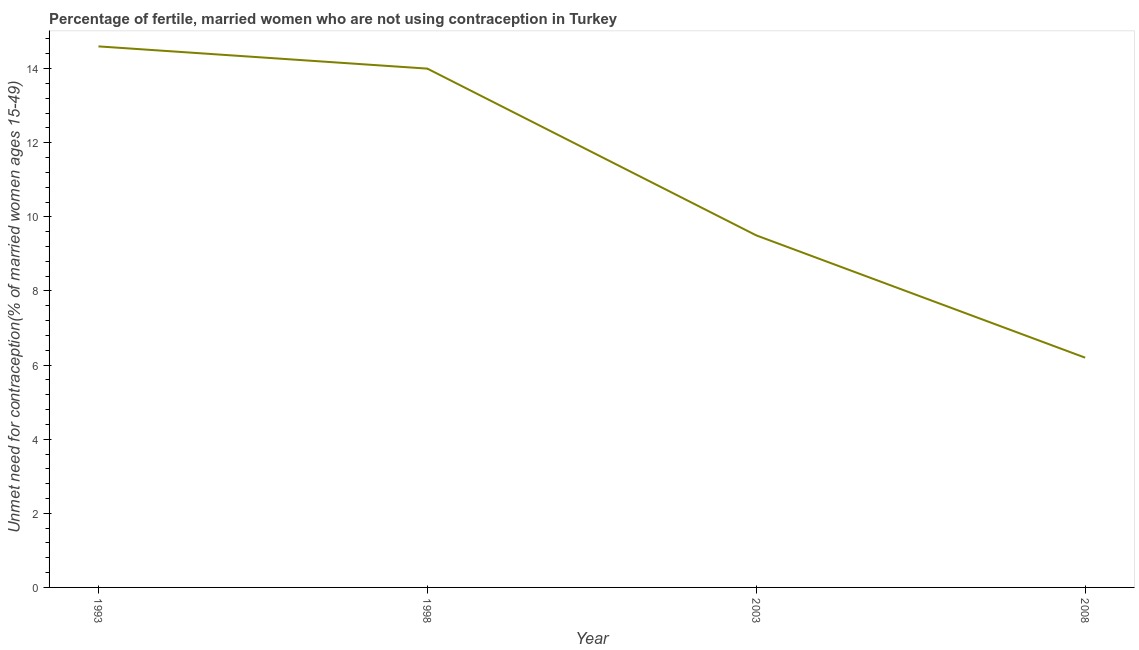What is the number of married women who are not using contraception in 2008?
Your answer should be very brief. 6.2. In which year was the number of married women who are not using contraception maximum?
Ensure brevity in your answer.  1993. What is the sum of the number of married women who are not using contraception?
Keep it short and to the point. 44.3. What is the average number of married women who are not using contraception per year?
Your answer should be compact. 11.08. What is the median number of married women who are not using contraception?
Your answer should be compact. 11.75. In how many years, is the number of married women who are not using contraception greater than 8.4 %?
Your answer should be compact. 3. What is the ratio of the number of married women who are not using contraception in 1993 to that in 1998?
Ensure brevity in your answer.  1.04. Is the number of married women who are not using contraception in 2003 less than that in 2008?
Give a very brief answer. No. What is the difference between the highest and the second highest number of married women who are not using contraception?
Offer a terse response. 0.6. What is the difference between the highest and the lowest number of married women who are not using contraception?
Your answer should be very brief. 8.4. Does the number of married women who are not using contraception monotonically increase over the years?
Make the answer very short. No. Are the values on the major ticks of Y-axis written in scientific E-notation?
Your answer should be very brief. No. Does the graph contain any zero values?
Provide a succinct answer. No. Does the graph contain grids?
Your response must be concise. No. What is the title of the graph?
Ensure brevity in your answer.  Percentage of fertile, married women who are not using contraception in Turkey. What is the label or title of the X-axis?
Your answer should be very brief. Year. What is the label or title of the Y-axis?
Ensure brevity in your answer.   Unmet need for contraception(% of married women ages 15-49). What is the  Unmet need for contraception(% of married women ages 15-49) of 1993?
Make the answer very short. 14.6. What is the  Unmet need for contraception(% of married women ages 15-49) of 2003?
Make the answer very short. 9.5. What is the difference between the  Unmet need for contraception(% of married women ages 15-49) in 1993 and 1998?
Offer a very short reply. 0.6. What is the difference between the  Unmet need for contraception(% of married women ages 15-49) in 1993 and 2008?
Make the answer very short. 8.4. What is the difference between the  Unmet need for contraception(% of married women ages 15-49) in 1998 and 2003?
Make the answer very short. 4.5. What is the difference between the  Unmet need for contraception(% of married women ages 15-49) in 1998 and 2008?
Your answer should be very brief. 7.8. What is the difference between the  Unmet need for contraception(% of married women ages 15-49) in 2003 and 2008?
Your response must be concise. 3.3. What is the ratio of the  Unmet need for contraception(% of married women ages 15-49) in 1993 to that in 1998?
Give a very brief answer. 1.04. What is the ratio of the  Unmet need for contraception(% of married women ages 15-49) in 1993 to that in 2003?
Offer a very short reply. 1.54. What is the ratio of the  Unmet need for contraception(% of married women ages 15-49) in 1993 to that in 2008?
Make the answer very short. 2.35. What is the ratio of the  Unmet need for contraception(% of married women ages 15-49) in 1998 to that in 2003?
Provide a succinct answer. 1.47. What is the ratio of the  Unmet need for contraception(% of married women ages 15-49) in 1998 to that in 2008?
Your response must be concise. 2.26. What is the ratio of the  Unmet need for contraception(% of married women ages 15-49) in 2003 to that in 2008?
Give a very brief answer. 1.53. 